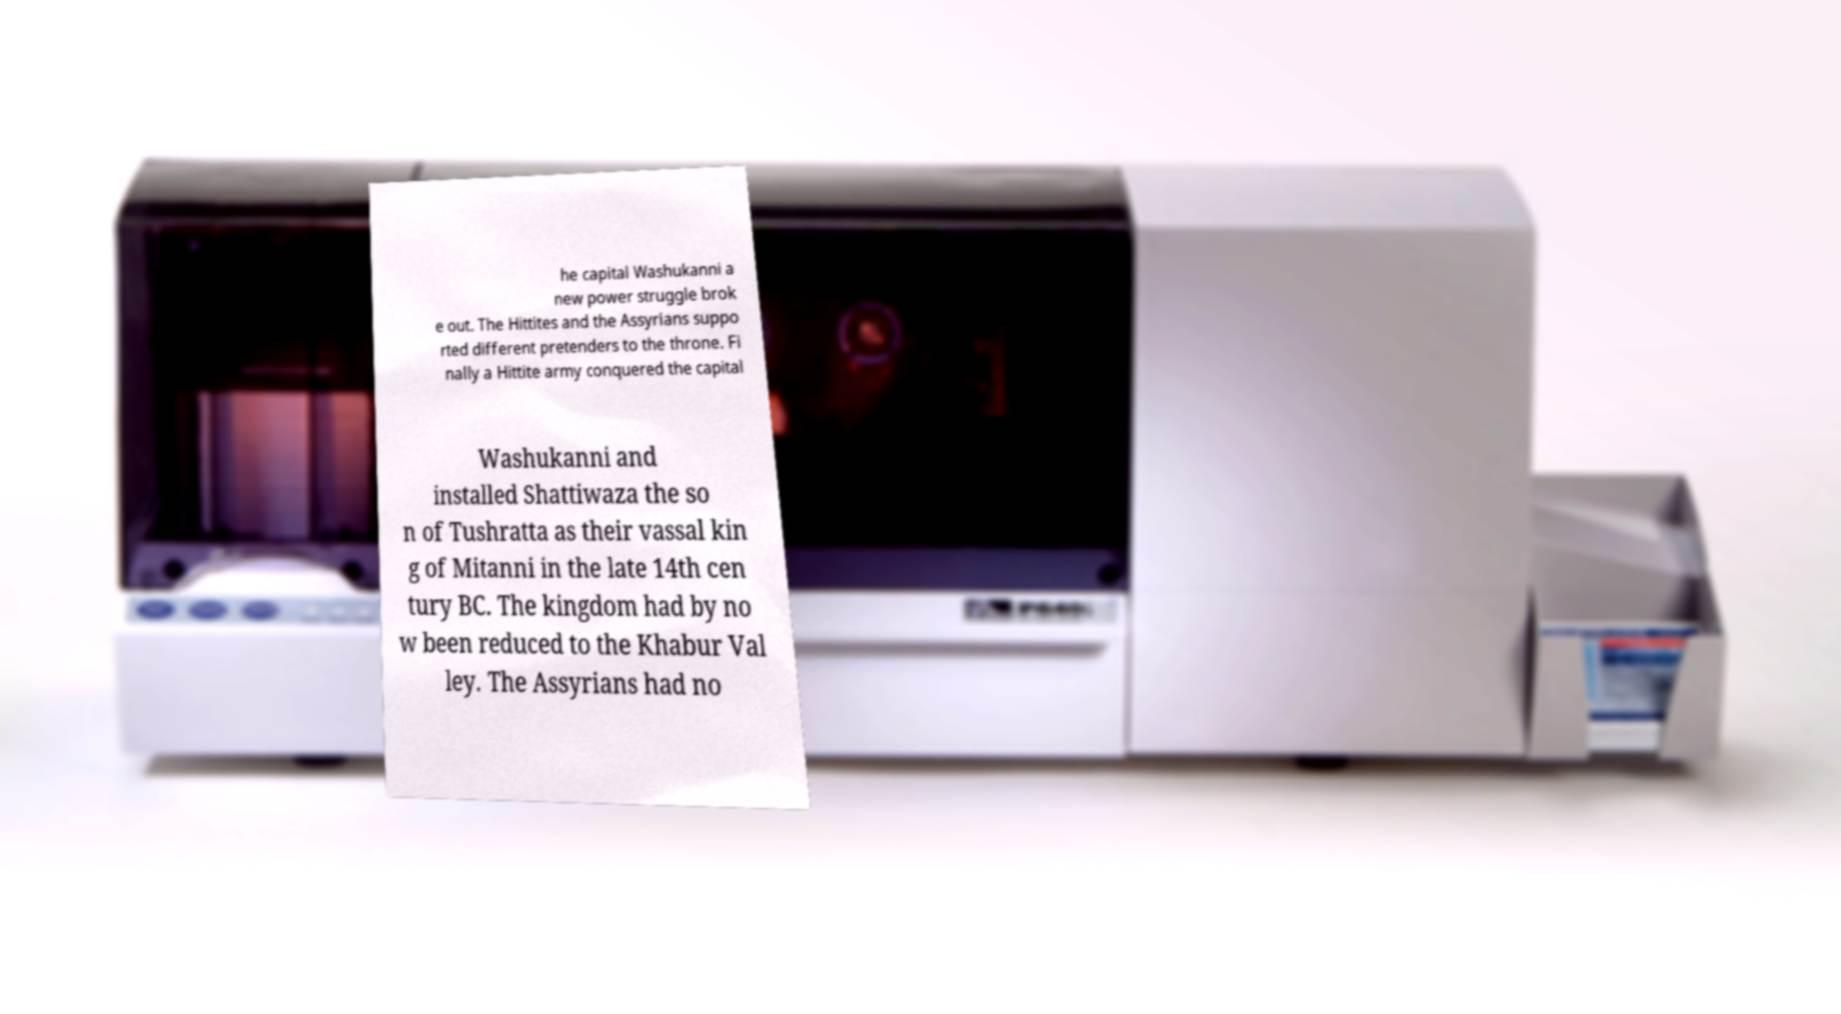Please read and relay the text visible in this image. What does it say? he capital Washukanni a new power struggle brok e out. The Hittites and the Assyrians suppo rted different pretenders to the throne. Fi nally a Hittite army conquered the capital Washukanni and installed Shattiwaza the so n of Tushratta as their vassal kin g of Mitanni in the late 14th cen tury BC. The kingdom had by no w been reduced to the Khabur Val ley. The Assyrians had no 